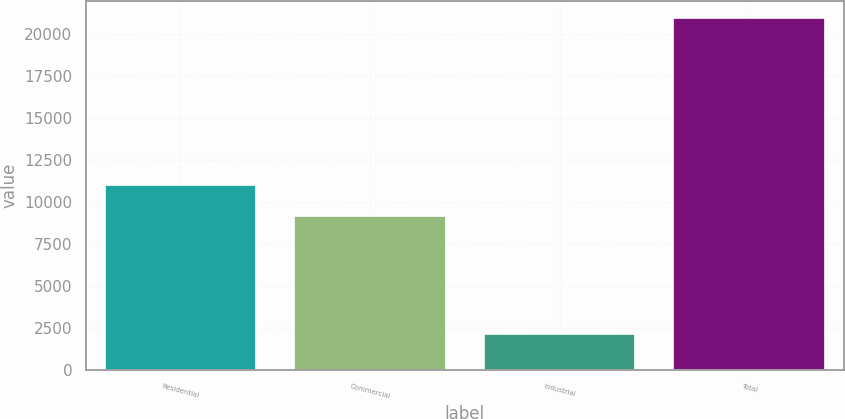Convert chart to OTSL. <chart><loc_0><loc_0><loc_500><loc_500><bar_chart><fcel>Residential<fcel>Commercial<fcel>Industrial<fcel>Total<nl><fcel>11041.3<fcel>9161<fcel>2146<fcel>20949<nl></chart> 